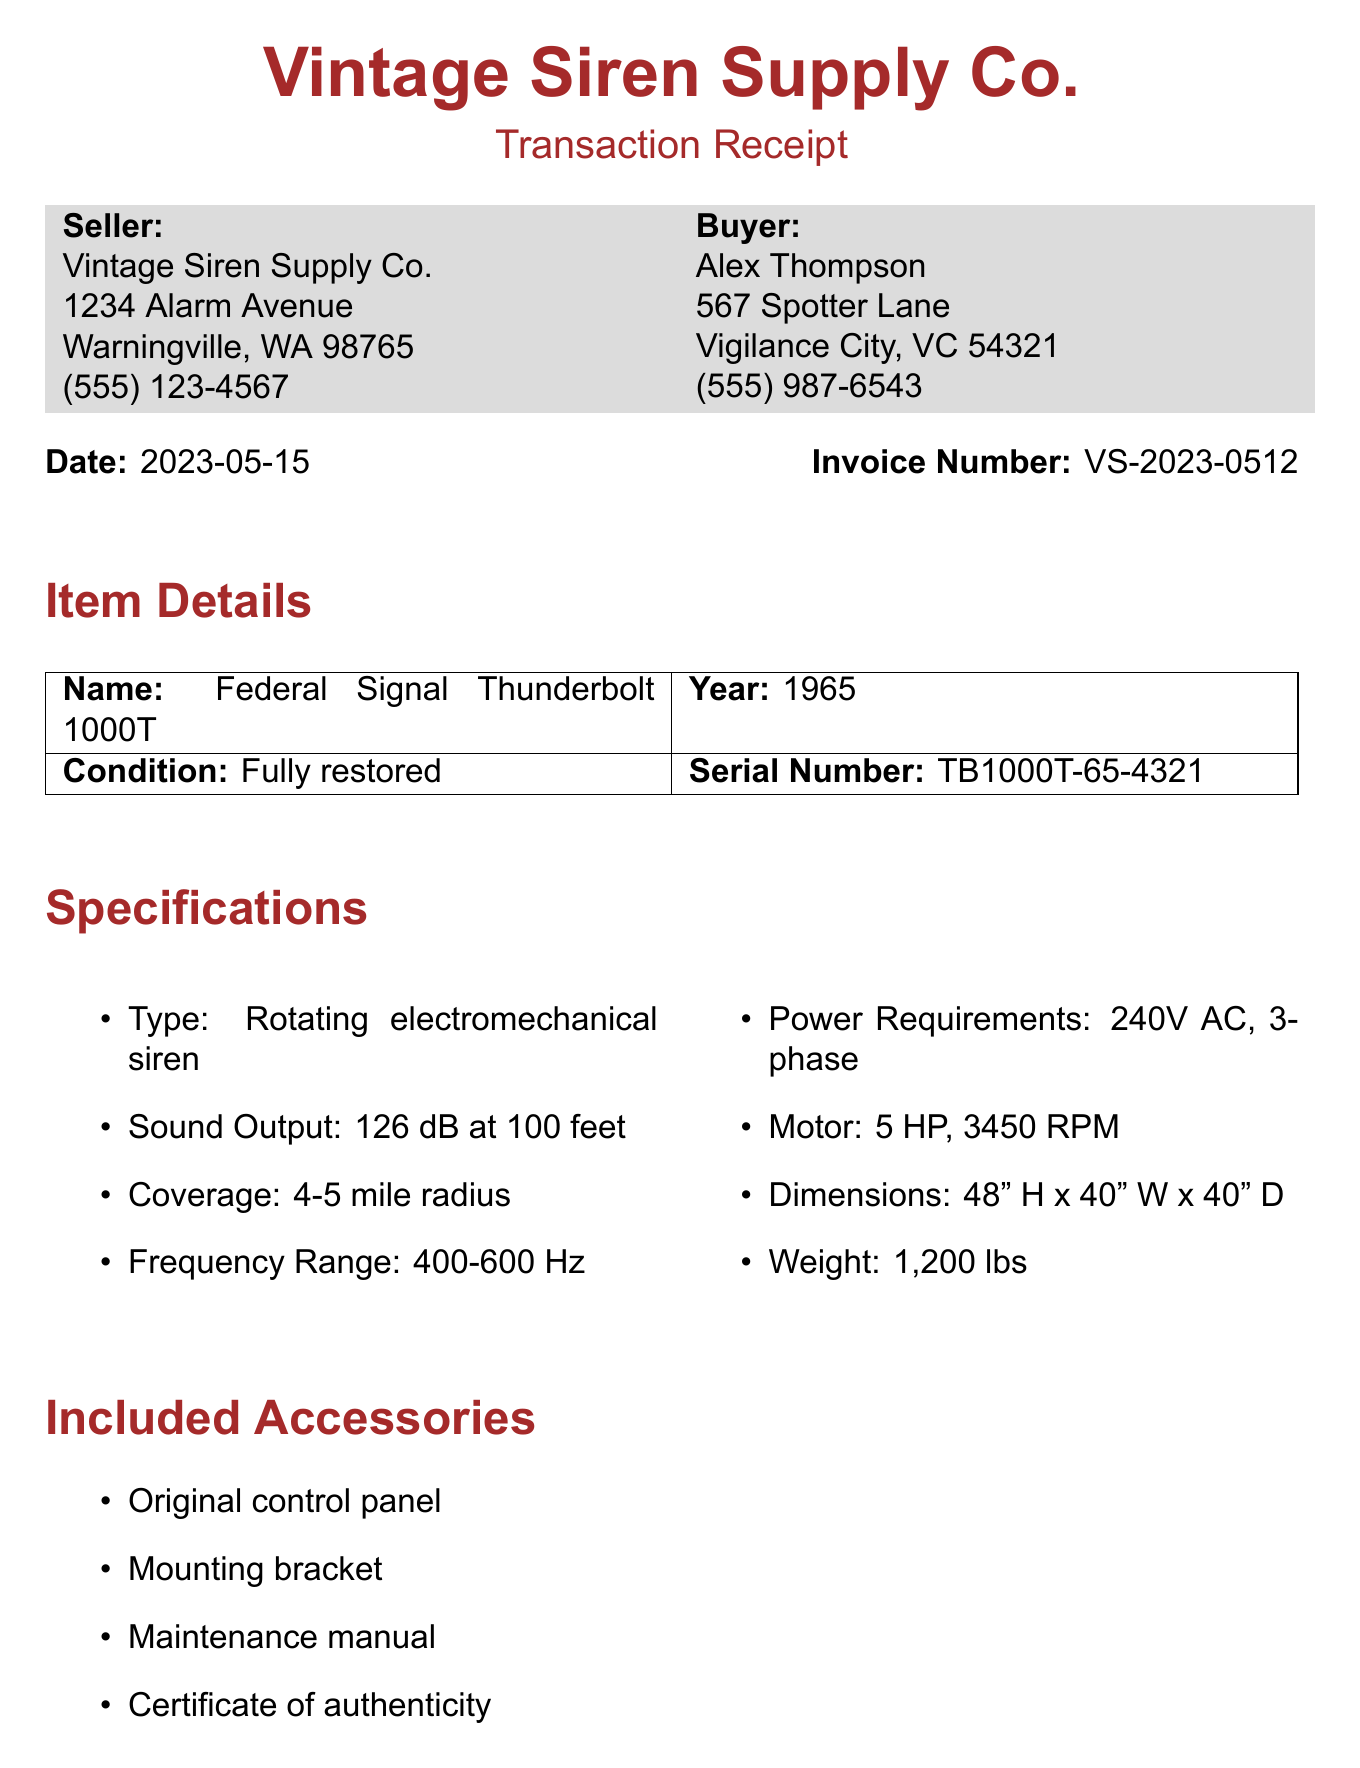What is the name of the seller? The name of the seller is found in the document under the seller's details.
Answer: Vintage Siren Supply Co What is the condition of the siren? The condition of the siren is described in the item details section of the document.
Answer: Fully restored What type of siren is included in the purchase? The type of the siren is mentioned in the specifications section, indicating its mechanics.
Answer: Rotating electromechanical siren What is the total price of the transaction? The total price is calculated as the sum of the base price, restoration fee, and shipping listed in the price breakdown.
Answer: $10,450.00 How many pounds does the siren weigh? The weight of the siren is specified in its specifications.
Answer: 1,200 lbs What is the payment method for this transaction? The payment method is provided in the document under payment details.
Answer: Wire transfer What warranty is provided with the siren purchase? The warranty details can be found in the warranty section of the document.
Answer: 90-day limited warranty on mechanical parts In what year was the siren manufactured? The year of manufacture is indicated in the item details section.
Answer: 1965 What is the shipping method stated in the document? The shipping method is listed specifically in the document under shipping details.
Answer: Freight carrier - White Glove Service 